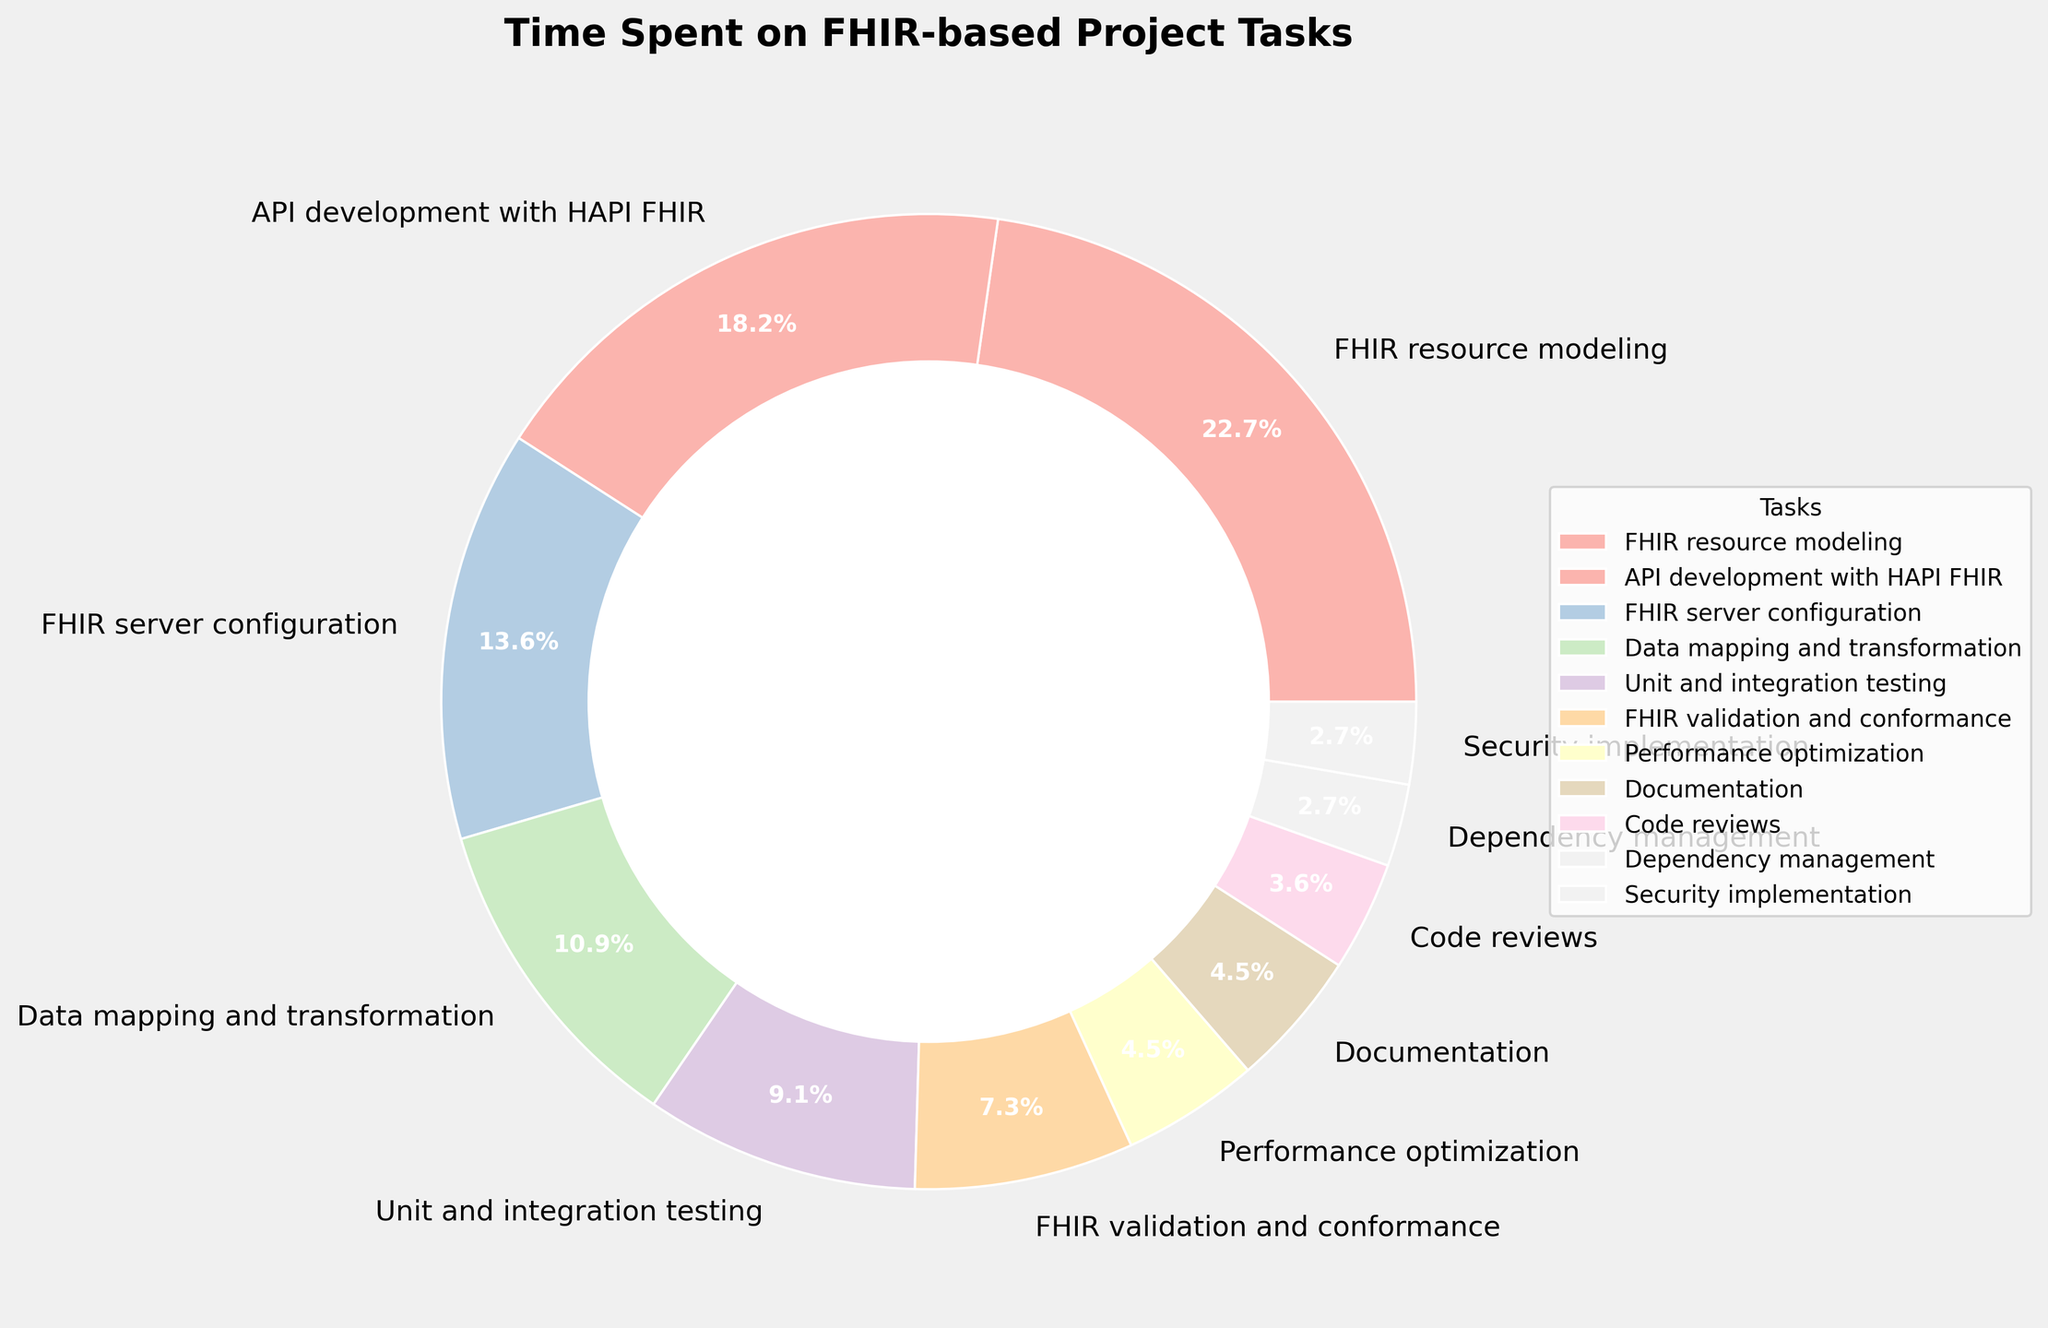Which task takes up the most time according to the pie chart? The largest section of the pie chart represents the task with the most time spent. By inspecting the sections and their labels, we see that "FHIR resource modeling" occupies 25% of the total time.
Answer: FHIR resource modeling Which tasks take 5% or less of the total time? By examining the pie chart, the sections labeled with 5% or less of the total time include: Performance optimization, Documentation, Code reviews, Dependency management, and Security implementation.
Answer: Performance optimization, Documentation, Code reviews, Dependency management, Security implementation How much more time is spent on "FHIR resource modeling" compared to "Security implementation"? "FHIR resource modeling" accounts for 25%, and "Security implementation" accounts for 3%. The difference is calculated as 25% - 3% = 22%.
Answer: 22% What is the combined percentage of time spent on "Unit and integration testing" and "FHIR server configuration"? "Unit and integration testing" takes 10% and "FHIR server configuration" takes 15%. Adding these together: 10% + 15% = 25%.
Answer: 25% What percentage of time is spent on tasks other than "FHIR resource modeling" and "API development with HAPI FHIR"? First, sum the percentages of "FHIR resource modeling" (25%) and "API development with HAPI FHIR" (20%). This gives 45%. Subtract this from 100% to get the remaining percentage: 100% - 45% = 55%.
Answer: 55% Compare the time percentages of "Data mapping and transformation" and "FHIR validation and conformance". Which one has a higher percentage? From the chart, "Data mapping and transformation" is 12% and "FHIR validation and conformance" is 8%. Comparing these, "Data mapping and transformation" has the higher percentage.
Answer: Data mapping and transformation Which task occupies the smallest section of the pie chart? The smallest section of the pie chart can be identified by the percentage labels. The smallest section is associated with the label "Dependency management", which is 3%.
Answer: Dependency management 